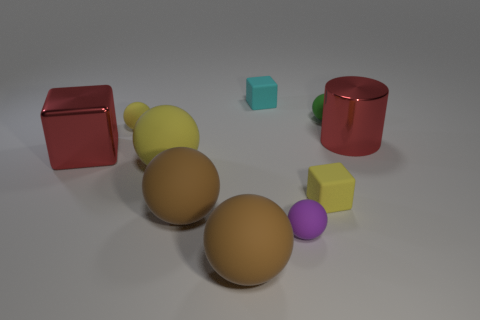Subtract all yellow spheres. How many spheres are left? 4 Subtract all tiny yellow spheres. How many spheres are left? 5 Subtract all blue balls. Subtract all green blocks. How many balls are left? 6 Subtract all cylinders. How many objects are left? 9 Subtract all big red shiny things. Subtract all purple objects. How many objects are left? 7 Add 1 small cyan matte cubes. How many small cyan matte cubes are left? 2 Add 8 metal things. How many metal things exist? 10 Subtract 0 gray cylinders. How many objects are left? 10 